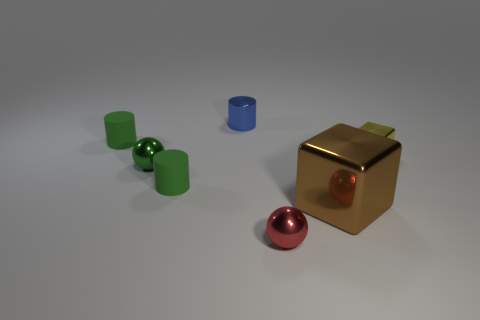Add 1 blue cylinders. How many objects exist? 8 Subtract all cylinders. How many objects are left? 4 Subtract 0 gray spheres. How many objects are left? 7 Subtract all small red shiny blocks. Subtract all tiny red metal things. How many objects are left? 6 Add 6 big objects. How many big objects are left? 7 Add 3 small yellow metal cubes. How many small yellow metal cubes exist? 4 